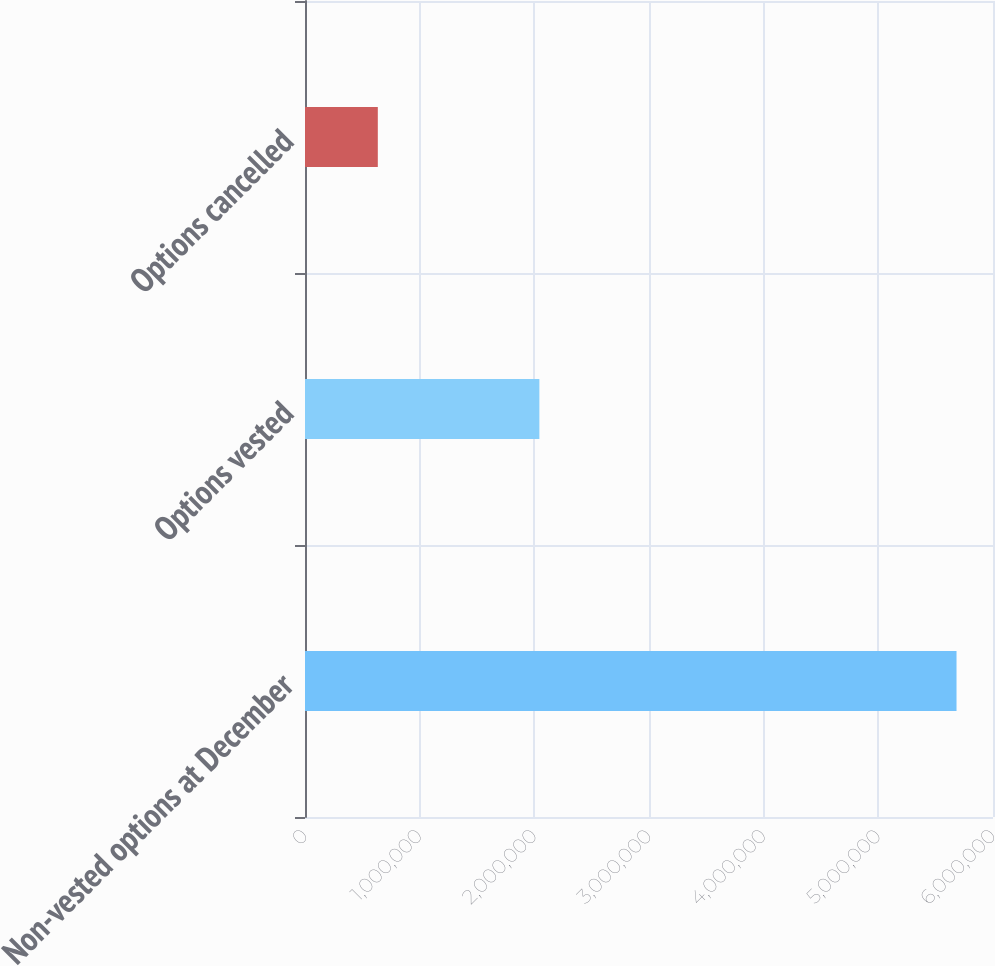Convert chart. <chart><loc_0><loc_0><loc_500><loc_500><bar_chart><fcel>Non-vested options at December<fcel>Options vested<fcel>Options cancelled<nl><fcel>5.68195e+06<fcel>2.04396e+06<fcel>635020<nl></chart> 